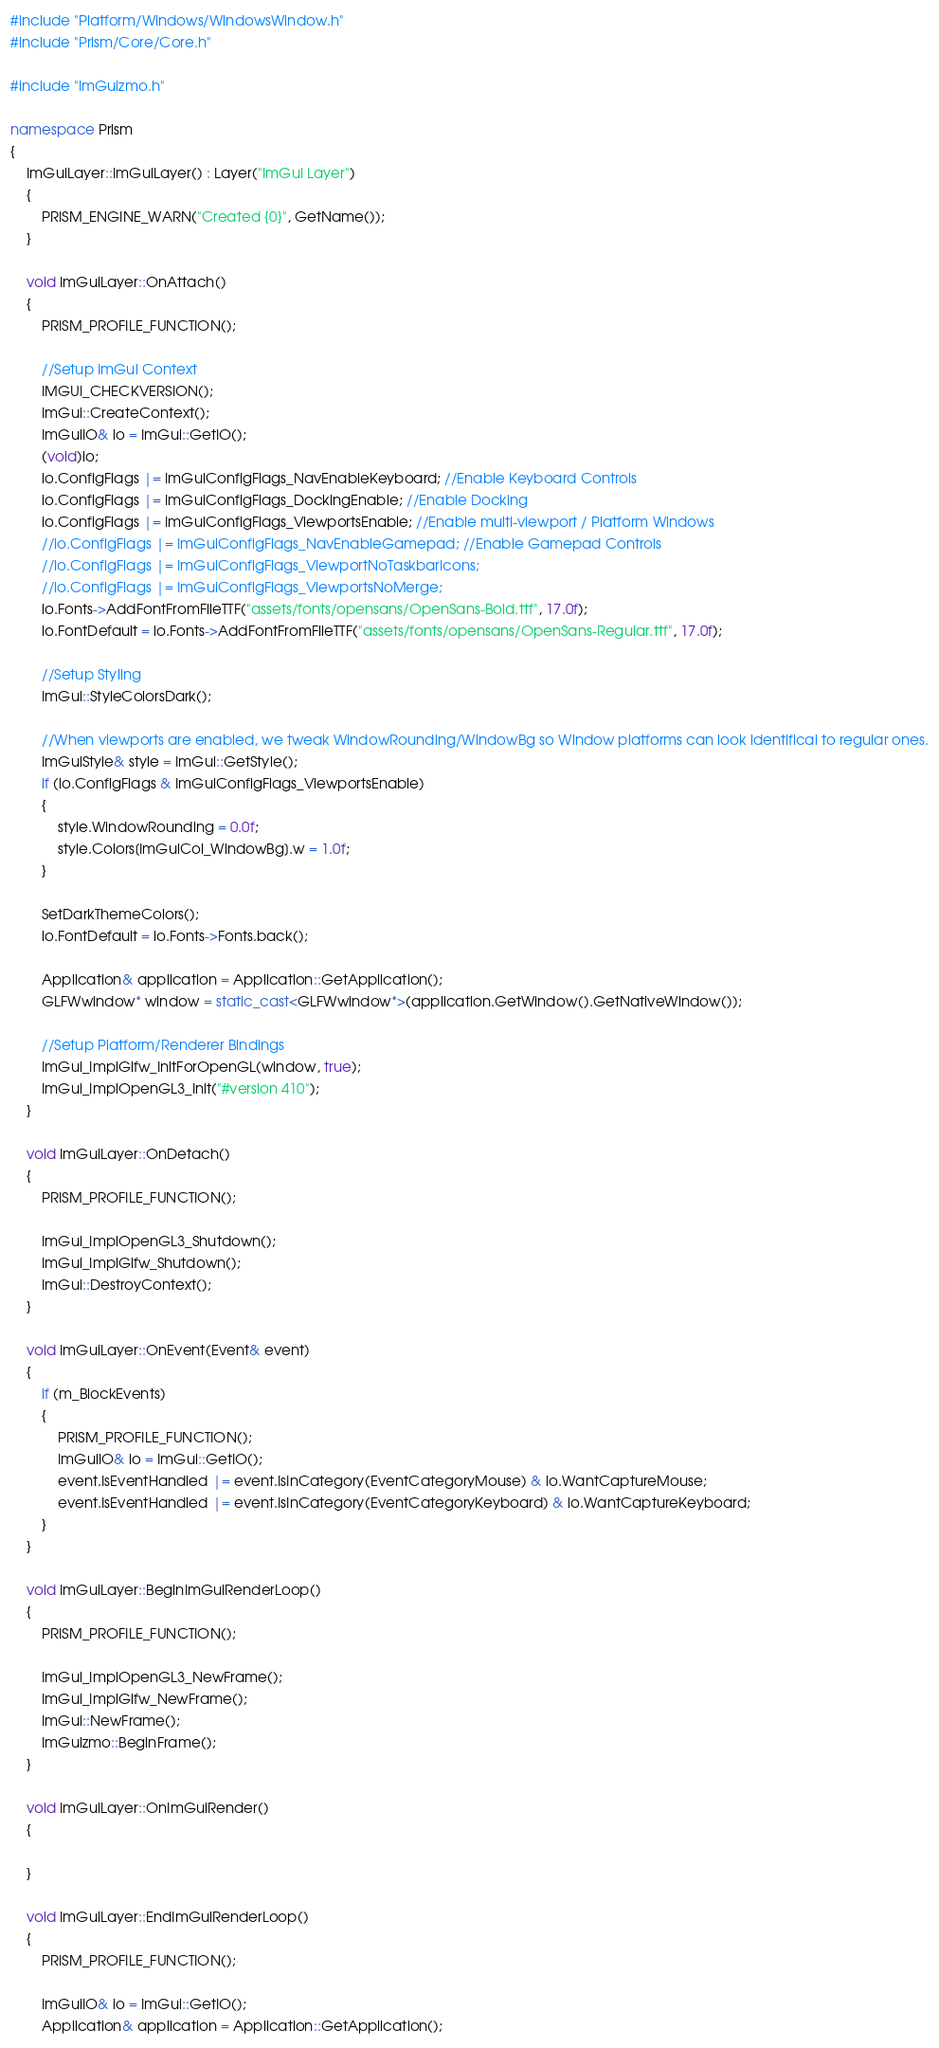<code> <loc_0><loc_0><loc_500><loc_500><_C++_>#include "Platform/Windows/WindowsWindow.h"
#include "Prism/Core/Core.h"

#include "ImGuizmo.h"

namespace Prism
{
	ImGuiLayer::ImGuiLayer() : Layer("ImGui Layer")
	{
		PRISM_ENGINE_WARN("Created {0}", GetName());
	}

	void ImGuiLayer::OnAttach()
	{
		PRISM_PROFILE_FUNCTION();

		//Setup ImGui Context
		IMGUI_CHECKVERSION();
        ImGui::CreateContext();
		ImGuiIO& io = ImGui::GetIO(); 
		(void)io;
		io.ConfigFlags |= ImGuiConfigFlags_NavEnableKeyboard; //Enable Keyboard Controls
		io.ConfigFlags |= ImGuiConfigFlags_DockingEnable; //Enable Docking
		io.ConfigFlags |= ImGuiConfigFlags_ViewportsEnable; //Enable multi-viewport / Platform Windows
		//io.ConfigFlags |= ImGuiConfigFlags_NavEnableGamepad; //Enable Gamepad Controls
		//io.ConfigFlags |= ImGuiConfigFlags_ViewportNoTaskbarIcons;
		//io.ConfigFlags |= ImGuiConfigFlags_ViewportsNoMerge;
		io.Fonts->AddFontFromFileTTF("assets/fonts/opensans/OpenSans-Bold.ttf", 17.0f);
		io.FontDefault = io.Fonts->AddFontFromFileTTF("assets/fonts/opensans/OpenSans-Regular.ttf", 17.0f);

		//Setup Styling
		ImGui::StyleColorsDark(); 

		//When viewports are enabled, we tweak WindowRounding/WindowBg so Window platforms can look identifical to regular ones.
		ImGuiStyle& style = ImGui::GetStyle();
		if (io.ConfigFlags & ImGuiConfigFlags_ViewportsEnable)
		{
			style.WindowRounding = 0.0f;
			style.Colors[ImGuiCol_WindowBg].w = 1.0f;
		}	

		SetDarkThemeColors();
		io.FontDefault = io.Fonts->Fonts.back();

		Application& application = Application::GetApplication();
		GLFWwindow* window = static_cast<GLFWwindow*>(application.GetWindow().GetNativeWindow());

		//Setup Platform/Renderer Bindings
		ImGui_ImplGlfw_InitForOpenGL(window, true);
		ImGui_ImplOpenGL3_Init("#version 410");
	}

	void ImGuiLayer::OnDetach()
	{
		PRISM_PROFILE_FUNCTION();

		ImGui_ImplOpenGL3_Shutdown();
		ImGui_ImplGlfw_Shutdown();
		ImGui::DestroyContext();
	}

	void ImGuiLayer::OnEvent(Event& event)
	{
		if (m_BlockEvents)
		{
			PRISM_PROFILE_FUNCTION();
			ImGuiIO& io = ImGui::GetIO();
			event.IsEventHandled |= event.IsInCategory(EventCategoryMouse) & io.WantCaptureMouse;
			event.IsEventHandled |= event.IsInCategory(EventCategoryKeyboard) & io.WantCaptureKeyboard;
		}
	}

	void ImGuiLayer::BeginImGuiRenderLoop()
	{
		PRISM_PROFILE_FUNCTION();

		ImGui_ImplOpenGL3_NewFrame();
		ImGui_ImplGlfw_NewFrame();
		ImGui::NewFrame();
		ImGuizmo::BeginFrame();
	}

	void ImGuiLayer::OnImGuiRender()
	{

	}

	void ImGuiLayer::EndImGuiRenderLoop()
	{
		PRISM_PROFILE_FUNCTION();

		ImGuiIO& io = ImGui::GetIO();
		Application& application = Application::GetApplication();</code> 